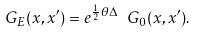<formula> <loc_0><loc_0><loc_500><loc_500>G _ { E } ( x , x ^ { \prime } ) = e ^ { \frac { 1 } { 2 } \theta \Delta } \ G _ { 0 } ( x , x ^ { \prime } ) .</formula> 